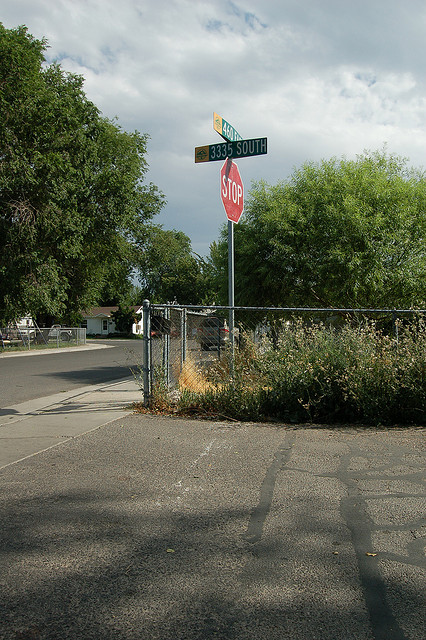Extract all visible text content from this image. 3335 south STOP 